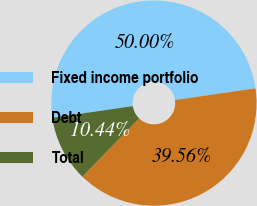Convert chart. <chart><loc_0><loc_0><loc_500><loc_500><pie_chart><fcel>Fixed income portfolio<fcel>Debt<fcel>Total<nl><fcel>50.0%<fcel>39.56%<fcel>10.44%<nl></chart> 